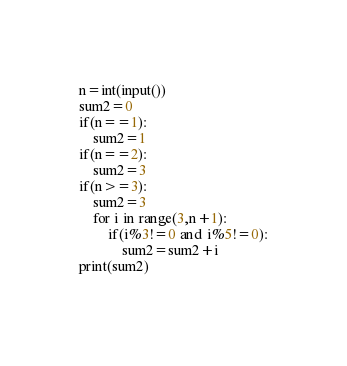Convert code to text. <code><loc_0><loc_0><loc_500><loc_500><_Python_>n=int(input())
sum2=0
if(n==1):
    sum2=1
if(n==2):
    sum2=3
if(n>=3):
    sum2=3
    for i in range(3,n+1):
        if(i%3!=0 and i%5!=0):
            sum2=sum2+i
print(sum2)
    </code> 